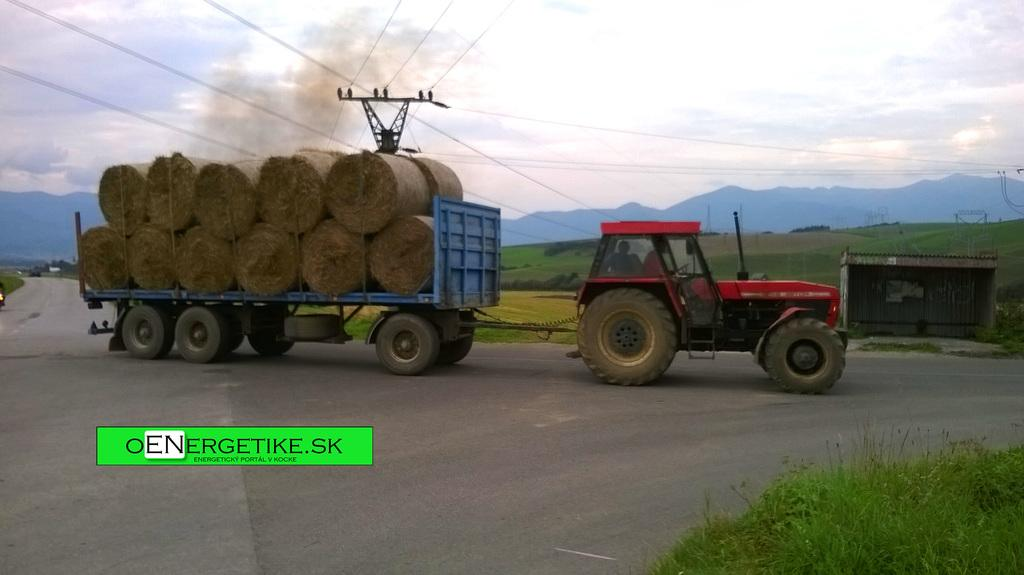What is the truck in the image carrying? The truck in the image is carrying a load. What structures can be seen in the image? There are towers, an electric pole, and a shed in the image. What are the cables in the image used for? The cables in the image are likely used for transmitting electricity or communication signals. What natural features are visible in the image? There are mountains and trees in the image. What is the weather like in the image? The presence of clouds in the sky suggests that the weather might be partly cloudy. What is the price of the industry depicted in the image? There is no industry depicted in the image, and therefore no price can be determined. 